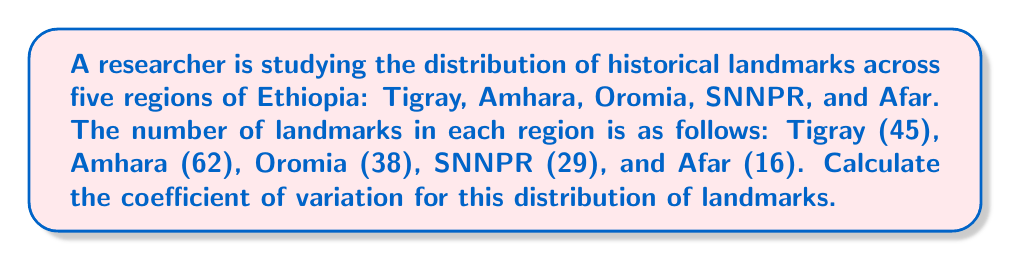Could you help me with this problem? To calculate the coefficient of variation (CV), we need to follow these steps:

1. Calculate the mean ($\mu$) of the distribution:
   $$\mu = \frac{45 + 62 + 38 + 29 + 16}{5} = 38$$

2. Calculate the variance ($\sigma^2$):
   $$\sigma^2 = \frac{(45-38)^2 + (62-38)^2 + (38-38)^2 + (29-38)^2 + (16-38)^2}{5}$$
   $$\sigma^2 = \frac{49 + 576 + 0 + 81 + 484}{5} = 238$$

3. Calculate the standard deviation ($\sigma$):
   $$\sigma = \sqrt{238} \approx 15.43$$

4. Calculate the coefficient of variation (CV):
   $$CV = \frac{\sigma}{\mu} \times 100\%$$
   $$CV = \frac{15.43}{38} \times 100\% \approx 40.61\%$$

The coefficient of variation is approximately 40.61%, indicating a relatively high degree of variability in the distribution of historical landmarks across these regions of Ethiopia.
Answer: 40.61% 